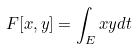<formula> <loc_0><loc_0><loc_500><loc_500>F [ x , y ] = \int _ { E } x y d t</formula> 